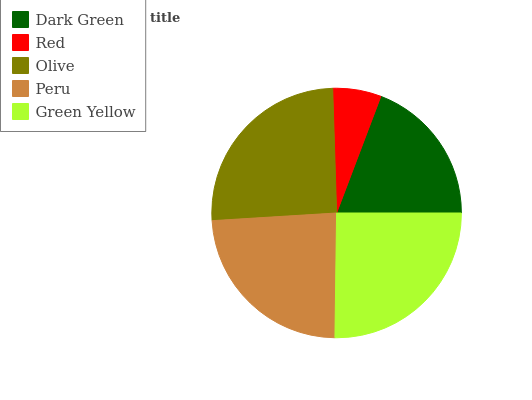Is Red the minimum?
Answer yes or no. Yes. Is Olive the maximum?
Answer yes or no. Yes. Is Olive the minimum?
Answer yes or no. No. Is Red the maximum?
Answer yes or no. No. Is Olive greater than Red?
Answer yes or no. Yes. Is Red less than Olive?
Answer yes or no. Yes. Is Red greater than Olive?
Answer yes or no. No. Is Olive less than Red?
Answer yes or no. No. Is Peru the high median?
Answer yes or no. Yes. Is Peru the low median?
Answer yes or no. Yes. Is Olive the high median?
Answer yes or no. No. Is Olive the low median?
Answer yes or no. No. 